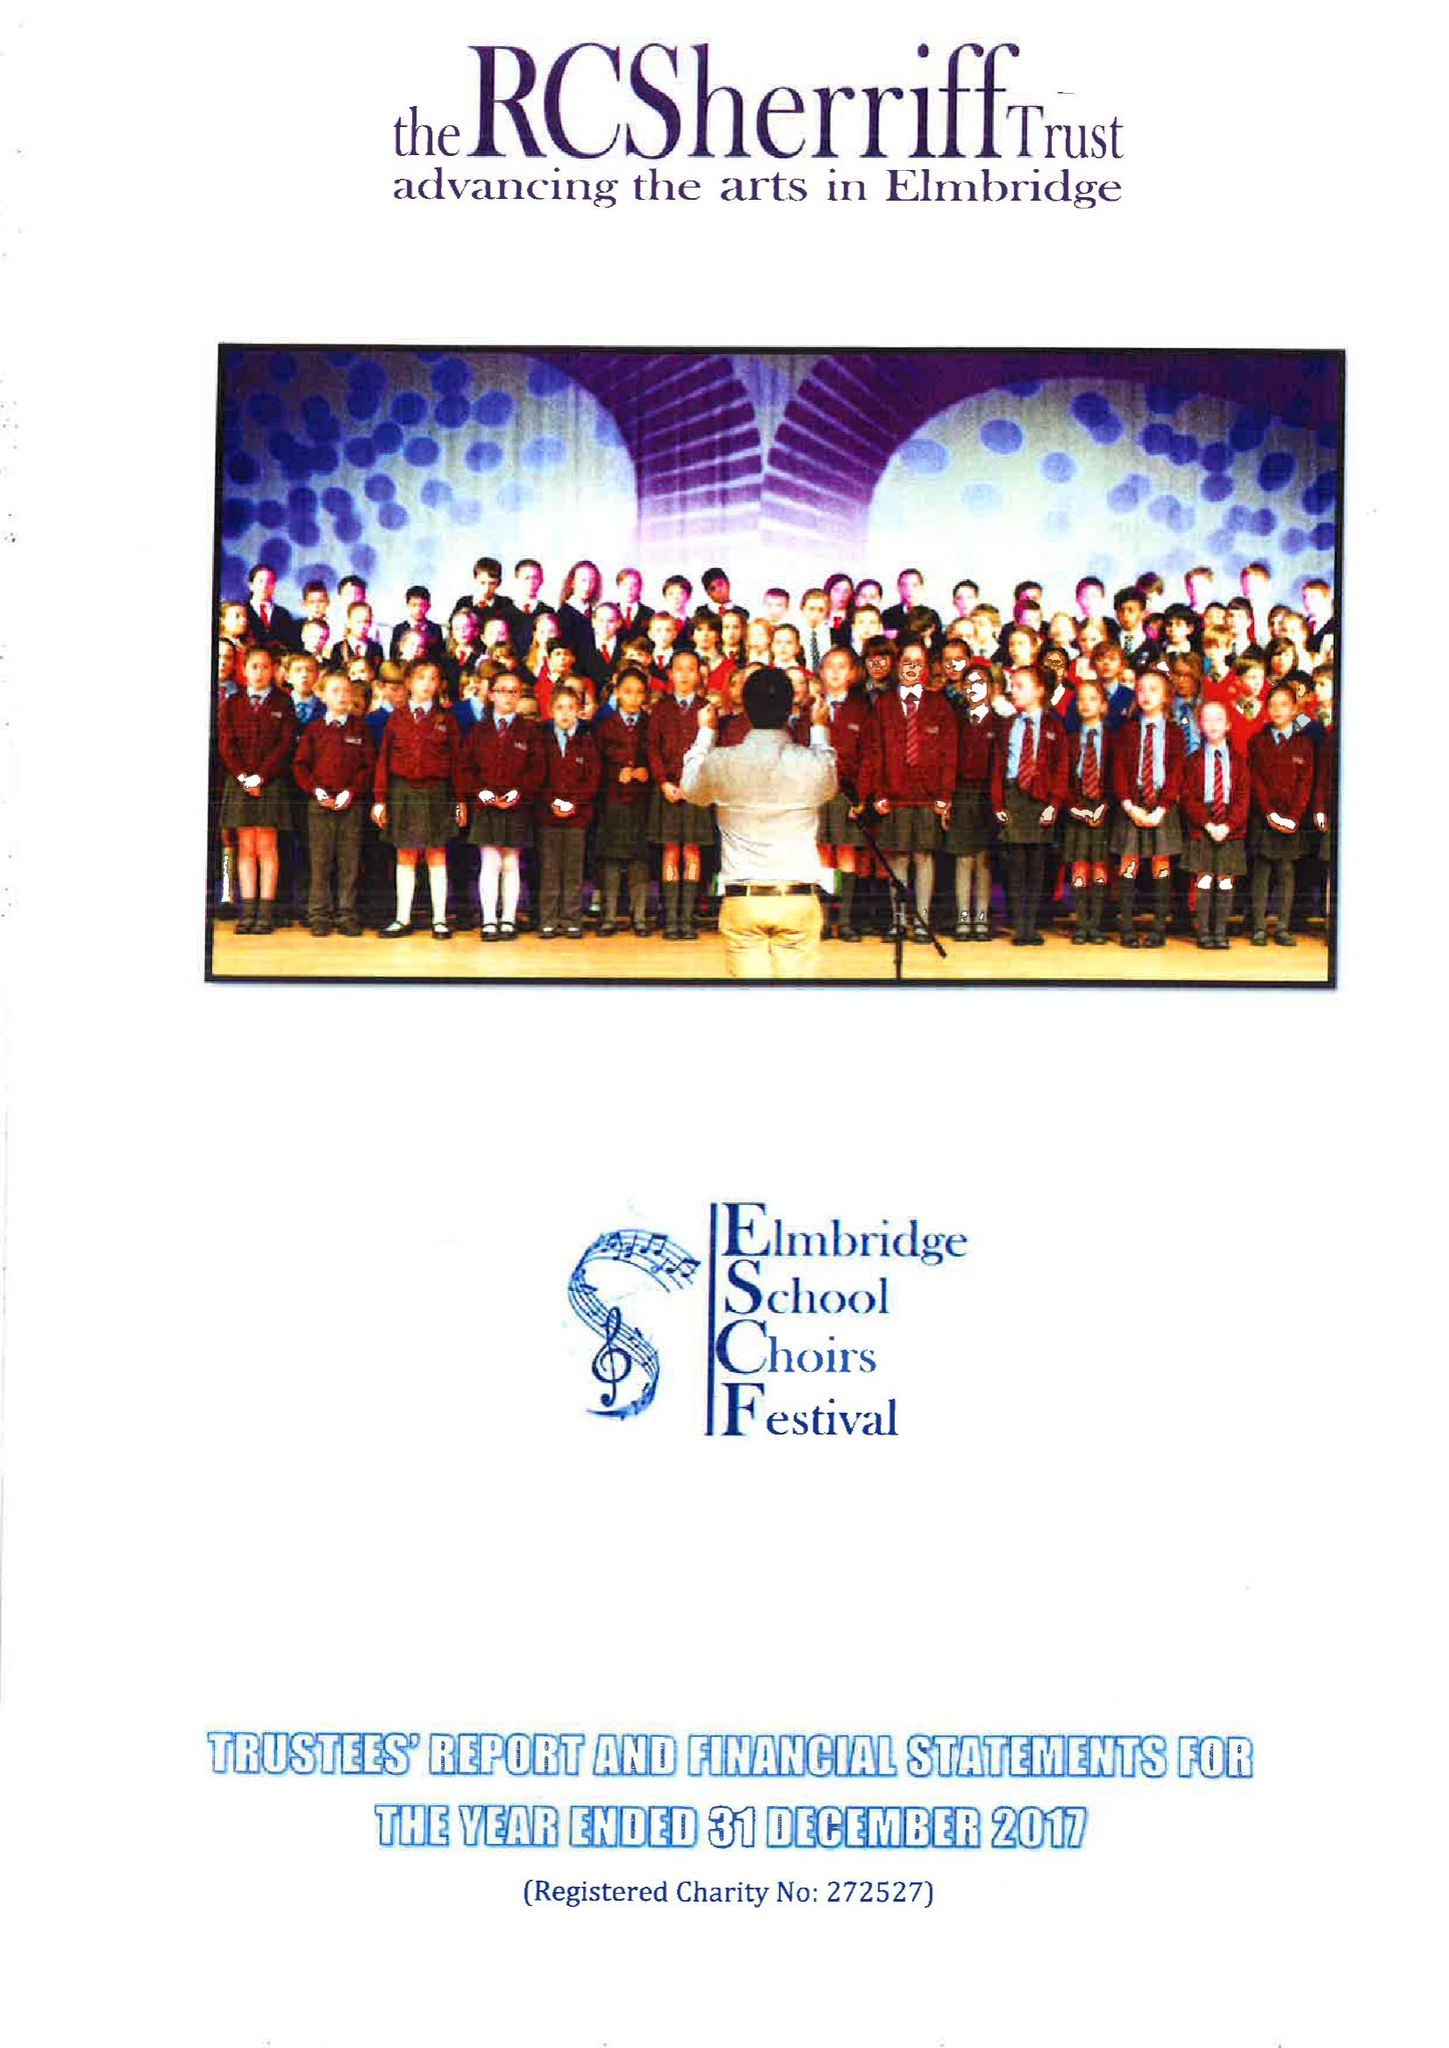What is the value for the spending_annually_in_british_pounds?
Answer the question using a single word or phrase. 217574.00 